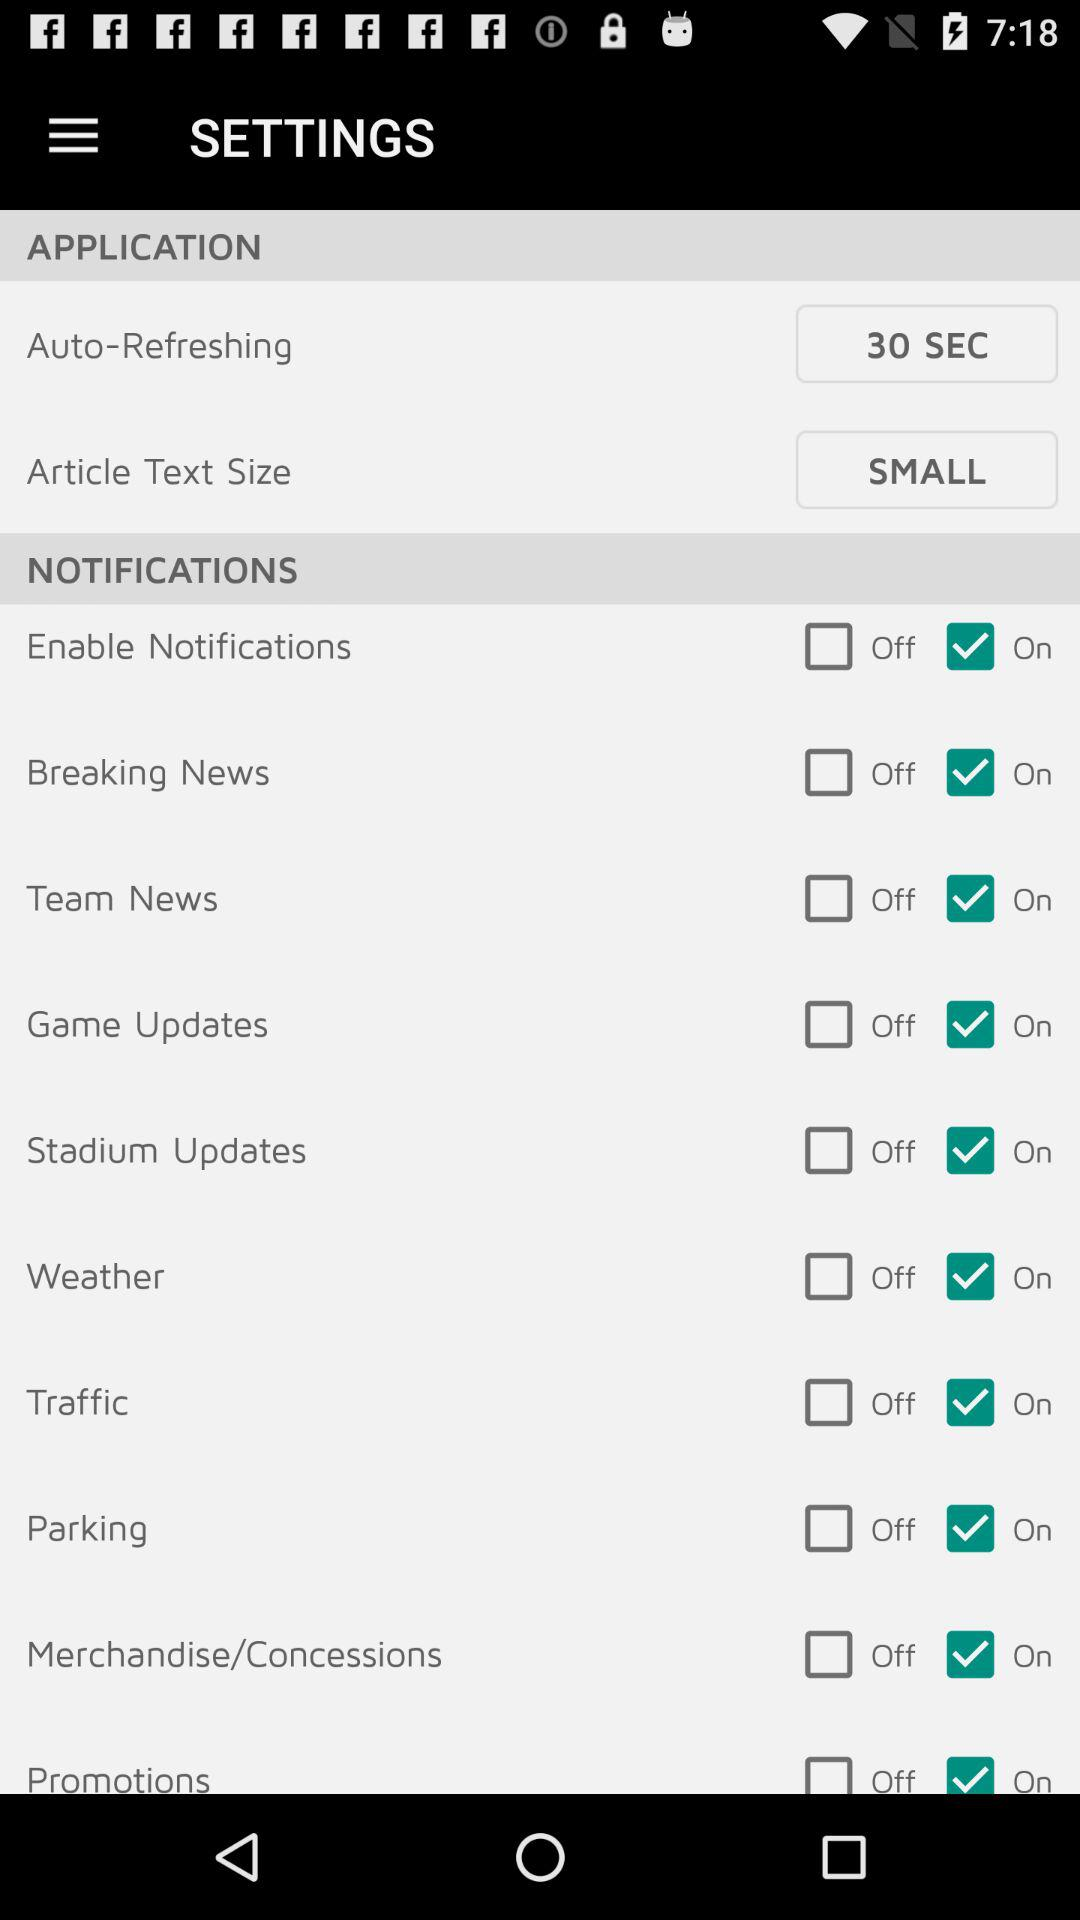What is the status of the "Breaking News"? The status is "On". 